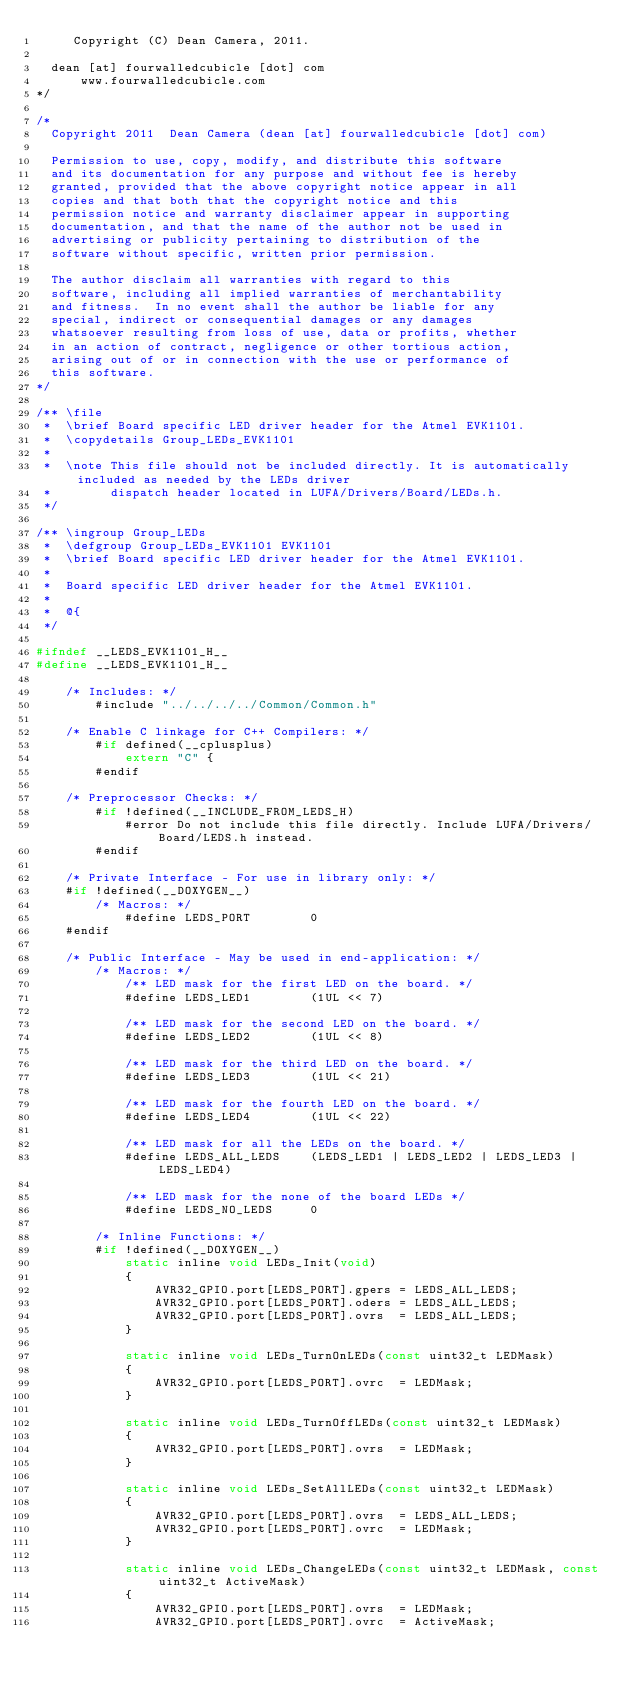<code> <loc_0><loc_0><loc_500><loc_500><_C_>     Copyright (C) Dean Camera, 2011.
              
  dean [at] fourwalledcubicle [dot] com
      www.fourwalledcubicle.com
*/

/*
  Copyright 2011  Dean Camera (dean [at] fourwalledcubicle [dot] com)

  Permission to use, copy, modify, and distribute this software
  and its documentation for any purpose and without fee is hereby
  granted, provided that the above copyright notice appear in all
  copies and that both that the copyright notice and this
  permission notice and warranty disclaimer appear in supporting
  documentation, and that the name of the author not be used in
  advertising or publicity pertaining to distribution of the
  software without specific, written prior permission.

  The author disclaim all warranties with regard to this
  software, including all implied warranties of merchantability
  and fitness.  In no event shall the author be liable for any
  special, indirect or consequential damages or any damages
  whatsoever resulting from loss of use, data or profits, whether
  in an action of contract, negligence or other tortious action,
  arising out of or in connection with the use or performance of
  this software.
*/

/** \file
 *  \brief Board specific LED driver header for the Atmel EVK1101.
 *  \copydetails Group_LEDs_EVK1101
 *
 *  \note This file should not be included directly. It is automatically included as needed by the LEDs driver
 *        dispatch header located in LUFA/Drivers/Board/LEDs.h.
 */

/** \ingroup Group_LEDs
 *  \defgroup Group_LEDs_EVK1101 EVK1101
 *  \brief Board specific LED driver header for the Atmel EVK1101.
 *
 *  Board specific LED driver header for the Atmel EVK1101.
 *
 *  @{
 */

#ifndef __LEDS_EVK1101_H__
#define __LEDS_EVK1101_H__

	/* Includes: */
		#include "../../../../Common/Common.h"

	/* Enable C linkage for C++ Compilers: */
		#if defined(__cplusplus)
			extern "C" {
		#endif

	/* Preprocessor Checks: */
		#if !defined(__INCLUDE_FROM_LEDS_H)
			#error Do not include this file directly. Include LUFA/Drivers/Board/LEDS.h instead.
		#endif

	/* Private Interface - For use in library only: */
	#if !defined(__DOXYGEN__)
		/* Macros: */
			#define LEDS_PORT        0
	#endif

	/* Public Interface - May be used in end-application: */
		/* Macros: */
			/** LED mask for the first LED on the board. */
			#define LEDS_LED1        (1UL << 7)

			/** LED mask for the second LED on the board. */
			#define LEDS_LED2        (1UL << 8)

			/** LED mask for the third LED on the board. */
			#define LEDS_LED3        (1UL << 21)

			/** LED mask for the fourth LED on the board. */
			#define LEDS_LED4        (1UL << 22)

			/** LED mask for all the LEDs on the board. */
			#define LEDS_ALL_LEDS    (LEDS_LED1 | LEDS_LED2 | LEDS_LED3 | LEDS_LED4)

			/** LED mask for the none of the board LEDs */
			#define LEDS_NO_LEDS     0

		/* Inline Functions: */
		#if !defined(__DOXYGEN__)
			static inline void LEDs_Init(void)
			{
				AVR32_GPIO.port[LEDS_PORT].gpers = LEDS_ALL_LEDS;
				AVR32_GPIO.port[LEDS_PORT].oders = LEDS_ALL_LEDS;
				AVR32_GPIO.port[LEDS_PORT].ovrs  = LEDS_ALL_LEDS;
			}
			
			static inline void LEDs_TurnOnLEDs(const uint32_t LEDMask)
			{
				AVR32_GPIO.port[LEDS_PORT].ovrc  = LEDMask;
			}

			static inline void LEDs_TurnOffLEDs(const uint32_t LEDMask)
			{
				AVR32_GPIO.port[LEDS_PORT].ovrs  = LEDMask;
			}

			static inline void LEDs_SetAllLEDs(const uint32_t LEDMask)
			{
				AVR32_GPIO.port[LEDS_PORT].ovrs  = LEDS_ALL_LEDS;
				AVR32_GPIO.port[LEDS_PORT].ovrc  = LEDMask;
			}
			
			static inline void LEDs_ChangeLEDs(const uint32_t LEDMask, const uint32_t ActiveMask)
			{
				AVR32_GPIO.port[LEDS_PORT].ovrs  = LEDMask;
				AVR32_GPIO.port[LEDS_PORT].ovrc  = ActiveMask;</code> 